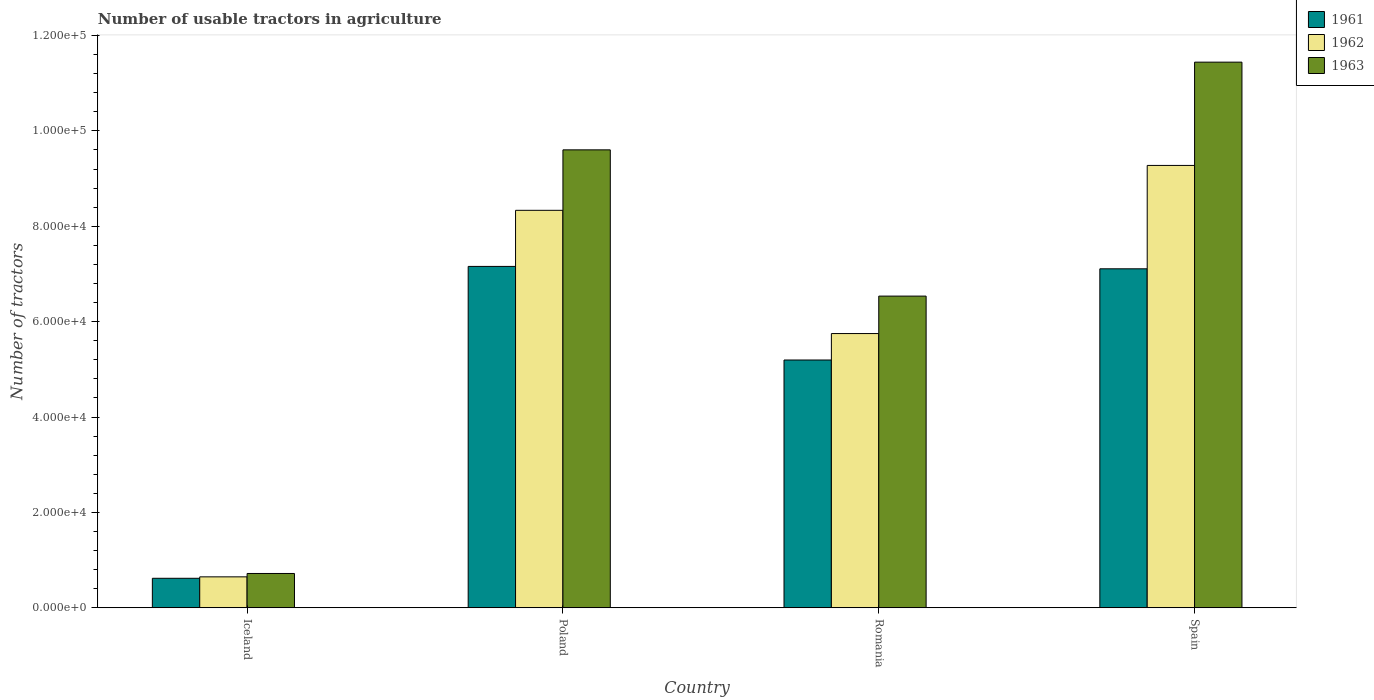How many different coloured bars are there?
Give a very brief answer. 3. How many groups of bars are there?
Your response must be concise. 4. Are the number of bars per tick equal to the number of legend labels?
Keep it short and to the point. Yes. How many bars are there on the 1st tick from the right?
Provide a succinct answer. 3. In how many cases, is the number of bars for a given country not equal to the number of legend labels?
Your answer should be compact. 0. What is the number of usable tractors in agriculture in 1961 in Spain?
Keep it short and to the point. 7.11e+04. Across all countries, what is the maximum number of usable tractors in agriculture in 1963?
Provide a succinct answer. 1.14e+05. Across all countries, what is the minimum number of usable tractors in agriculture in 1963?
Offer a very short reply. 7187. In which country was the number of usable tractors in agriculture in 1961 minimum?
Your response must be concise. Iceland. What is the total number of usable tractors in agriculture in 1963 in the graph?
Your answer should be very brief. 2.83e+05. What is the difference between the number of usable tractors in agriculture in 1962 in Poland and that in Romania?
Provide a short and direct response. 2.58e+04. What is the difference between the number of usable tractors in agriculture in 1961 in Romania and the number of usable tractors in agriculture in 1963 in Iceland?
Provide a short and direct response. 4.48e+04. What is the average number of usable tractors in agriculture in 1961 per country?
Your response must be concise. 5.02e+04. What is the difference between the number of usable tractors in agriculture of/in 1961 and number of usable tractors in agriculture of/in 1963 in Iceland?
Offer a very short reply. -1010. What is the ratio of the number of usable tractors in agriculture in 1963 in Poland to that in Romania?
Provide a short and direct response. 1.47. Is the number of usable tractors in agriculture in 1962 in Poland less than that in Romania?
Provide a short and direct response. No. Is the difference between the number of usable tractors in agriculture in 1961 in Poland and Spain greater than the difference between the number of usable tractors in agriculture in 1963 in Poland and Spain?
Your answer should be compact. Yes. What is the difference between the highest and the second highest number of usable tractors in agriculture in 1961?
Ensure brevity in your answer.  -1.96e+04. What is the difference between the highest and the lowest number of usable tractors in agriculture in 1963?
Your response must be concise. 1.07e+05. In how many countries, is the number of usable tractors in agriculture in 1963 greater than the average number of usable tractors in agriculture in 1963 taken over all countries?
Provide a short and direct response. 2. Is the sum of the number of usable tractors in agriculture in 1963 in Romania and Spain greater than the maximum number of usable tractors in agriculture in 1962 across all countries?
Make the answer very short. Yes. What does the 1st bar from the left in Iceland represents?
Make the answer very short. 1961. What does the 1st bar from the right in Poland represents?
Provide a succinct answer. 1963. Is it the case that in every country, the sum of the number of usable tractors in agriculture in 1963 and number of usable tractors in agriculture in 1961 is greater than the number of usable tractors in agriculture in 1962?
Offer a very short reply. Yes. What is the difference between two consecutive major ticks on the Y-axis?
Ensure brevity in your answer.  2.00e+04. Does the graph contain grids?
Ensure brevity in your answer.  No. How many legend labels are there?
Make the answer very short. 3. What is the title of the graph?
Offer a very short reply. Number of usable tractors in agriculture. Does "1997" appear as one of the legend labels in the graph?
Offer a terse response. No. What is the label or title of the Y-axis?
Your answer should be compact. Number of tractors. What is the Number of tractors of 1961 in Iceland?
Offer a very short reply. 6177. What is the Number of tractors of 1962 in Iceland?
Give a very brief answer. 6479. What is the Number of tractors in 1963 in Iceland?
Keep it short and to the point. 7187. What is the Number of tractors in 1961 in Poland?
Make the answer very short. 7.16e+04. What is the Number of tractors of 1962 in Poland?
Give a very brief answer. 8.33e+04. What is the Number of tractors of 1963 in Poland?
Provide a short and direct response. 9.60e+04. What is the Number of tractors in 1961 in Romania?
Provide a short and direct response. 5.20e+04. What is the Number of tractors of 1962 in Romania?
Ensure brevity in your answer.  5.75e+04. What is the Number of tractors in 1963 in Romania?
Your answer should be very brief. 6.54e+04. What is the Number of tractors in 1961 in Spain?
Make the answer very short. 7.11e+04. What is the Number of tractors in 1962 in Spain?
Your answer should be compact. 9.28e+04. What is the Number of tractors in 1963 in Spain?
Your answer should be compact. 1.14e+05. Across all countries, what is the maximum Number of tractors in 1961?
Keep it short and to the point. 7.16e+04. Across all countries, what is the maximum Number of tractors of 1962?
Your response must be concise. 9.28e+04. Across all countries, what is the maximum Number of tractors of 1963?
Make the answer very short. 1.14e+05. Across all countries, what is the minimum Number of tractors in 1961?
Give a very brief answer. 6177. Across all countries, what is the minimum Number of tractors in 1962?
Provide a short and direct response. 6479. Across all countries, what is the minimum Number of tractors in 1963?
Give a very brief answer. 7187. What is the total Number of tractors in 1961 in the graph?
Provide a short and direct response. 2.01e+05. What is the total Number of tractors in 1962 in the graph?
Your answer should be compact. 2.40e+05. What is the total Number of tractors of 1963 in the graph?
Give a very brief answer. 2.83e+05. What is the difference between the Number of tractors of 1961 in Iceland and that in Poland?
Your answer should be very brief. -6.54e+04. What is the difference between the Number of tractors of 1962 in Iceland and that in Poland?
Provide a short and direct response. -7.69e+04. What is the difference between the Number of tractors in 1963 in Iceland and that in Poland?
Offer a very short reply. -8.88e+04. What is the difference between the Number of tractors in 1961 in Iceland and that in Romania?
Your answer should be very brief. -4.58e+04. What is the difference between the Number of tractors of 1962 in Iceland and that in Romania?
Your answer should be compact. -5.10e+04. What is the difference between the Number of tractors in 1963 in Iceland and that in Romania?
Your response must be concise. -5.82e+04. What is the difference between the Number of tractors of 1961 in Iceland and that in Spain?
Keep it short and to the point. -6.49e+04. What is the difference between the Number of tractors of 1962 in Iceland and that in Spain?
Your answer should be very brief. -8.63e+04. What is the difference between the Number of tractors in 1963 in Iceland and that in Spain?
Ensure brevity in your answer.  -1.07e+05. What is the difference between the Number of tractors of 1961 in Poland and that in Romania?
Keep it short and to the point. 1.96e+04. What is the difference between the Number of tractors of 1962 in Poland and that in Romania?
Provide a short and direct response. 2.58e+04. What is the difference between the Number of tractors of 1963 in Poland and that in Romania?
Your answer should be compact. 3.07e+04. What is the difference between the Number of tractors of 1962 in Poland and that in Spain?
Your response must be concise. -9414. What is the difference between the Number of tractors in 1963 in Poland and that in Spain?
Your answer should be compact. -1.84e+04. What is the difference between the Number of tractors of 1961 in Romania and that in Spain?
Your response must be concise. -1.91e+04. What is the difference between the Number of tractors in 1962 in Romania and that in Spain?
Offer a terse response. -3.53e+04. What is the difference between the Number of tractors of 1963 in Romania and that in Spain?
Keep it short and to the point. -4.91e+04. What is the difference between the Number of tractors of 1961 in Iceland and the Number of tractors of 1962 in Poland?
Offer a very short reply. -7.72e+04. What is the difference between the Number of tractors of 1961 in Iceland and the Number of tractors of 1963 in Poland?
Ensure brevity in your answer.  -8.98e+04. What is the difference between the Number of tractors of 1962 in Iceland and the Number of tractors of 1963 in Poland?
Keep it short and to the point. -8.95e+04. What is the difference between the Number of tractors of 1961 in Iceland and the Number of tractors of 1962 in Romania?
Give a very brief answer. -5.13e+04. What is the difference between the Number of tractors of 1961 in Iceland and the Number of tractors of 1963 in Romania?
Provide a short and direct response. -5.92e+04. What is the difference between the Number of tractors in 1962 in Iceland and the Number of tractors in 1963 in Romania?
Offer a terse response. -5.89e+04. What is the difference between the Number of tractors in 1961 in Iceland and the Number of tractors in 1962 in Spain?
Ensure brevity in your answer.  -8.66e+04. What is the difference between the Number of tractors in 1961 in Iceland and the Number of tractors in 1963 in Spain?
Give a very brief answer. -1.08e+05. What is the difference between the Number of tractors of 1962 in Iceland and the Number of tractors of 1963 in Spain?
Provide a succinct answer. -1.08e+05. What is the difference between the Number of tractors in 1961 in Poland and the Number of tractors in 1962 in Romania?
Offer a terse response. 1.41e+04. What is the difference between the Number of tractors in 1961 in Poland and the Number of tractors in 1963 in Romania?
Offer a very short reply. 6226. What is the difference between the Number of tractors in 1962 in Poland and the Number of tractors in 1963 in Romania?
Offer a very short reply. 1.80e+04. What is the difference between the Number of tractors in 1961 in Poland and the Number of tractors in 1962 in Spain?
Offer a very short reply. -2.12e+04. What is the difference between the Number of tractors of 1961 in Poland and the Number of tractors of 1963 in Spain?
Provide a short and direct response. -4.28e+04. What is the difference between the Number of tractors in 1962 in Poland and the Number of tractors in 1963 in Spain?
Provide a succinct answer. -3.11e+04. What is the difference between the Number of tractors in 1961 in Romania and the Number of tractors in 1962 in Spain?
Offer a very short reply. -4.08e+04. What is the difference between the Number of tractors of 1961 in Romania and the Number of tractors of 1963 in Spain?
Provide a short and direct response. -6.25e+04. What is the difference between the Number of tractors in 1962 in Romania and the Number of tractors in 1963 in Spain?
Make the answer very short. -5.69e+04. What is the average Number of tractors in 1961 per country?
Provide a succinct answer. 5.02e+04. What is the average Number of tractors of 1962 per country?
Offer a terse response. 6.00e+04. What is the average Number of tractors of 1963 per country?
Your response must be concise. 7.07e+04. What is the difference between the Number of tractors of 1961 and Number of tractors of 1962 in Iceland?
Offer a very short reply. -302. What is the difference between the Number of tractors in 1961 and Number of tractors in 1963 in Iceland?
Keep it short and to the point. -1010. What is the difference between the Number of tractors in 1962 and Number of tractors in 1963 in Iceland?
Keep it short and to the point. -708. What is the difference between the Number of tractors of 1961 and Number of tractors of 1962 in Poland?
Provide a short and direct response. -1.18e+04. What is the difference between the Number of tractors of 1961 and Number of tractors of 1963 in Poland?
Your response must be concise. -2.44e+04. What is the difference between the Number of tractors in 1962 and Number of tractors in 1963 in Poland?
Make the answer very short. -1.27e+04. What is the difference between the Number of tractors in 1961 and Number of tractors in 1962 in Romania?
Provide a short and direct response. -5548. What is the difference between the Number of tractors in 1961 and Number of tractors in 1963 in Romania?
Offer a very short reply. -1.34e+04. What is the difference between the Number of tractors of 1962 and Number of tractors of 1963 in Romania?
Offer a very short reply. -7851. What is the difference between the Number of tractors of 1961 and Number of tractors of 1962 in Spain?
Give a very brief answer. -2.17e+04. What is the difference between the Number of tractors in 1961 and Number of tractors in 1963 in Spain?
Keep it short and to the point. -4.33e+04. What is the difference between the Number of tractors in 1962 and Number of tractors in 1963 in Spain?
Provide a short and direct response. -2.17e+04. What is the ratio of the Number of tractors of 1961 in Iceland to that in Poland?
Make the answer very short. 0.09. What is the ratio of the Number of tractors in 1962 in Iceland to that in Poland?
Provide a short and direct response. 0.08. What is the ratio of the Number of tractors in 1963 in Iceland to that in Poland?
Offer a very short reply. 0.07. What is the ratio of the Number of tractors of 1961 in Iceland to that in Romania?
Offer a terse response. 0.12. What is the ratio of the Number of tractors in 1962 in Iceland to that in Romania?
Offer a terse response. 0.11. What is the ratio of the Number of tractors of 1963 in Iceland to that in Romania?
Offer a terse response. 0.11. What is the ratio of the Number of tractors in 1961 in Iceland to that in Spain?
Your answer should be very brief. 0.09. What is the ratio of the Number of tractors in 1962 in Iceland to that in Spain?
Your response must be concise. 0.07. What is the ratio of the Number of tractors in 1963 in Iceland to that in Spain?
Provide a succinct answer. 0.06. What is the ratio of the Number of tractors in 1961 in Poland to that in Romania?
Your response must be concise. 1.38. What is the ratio of the Number of tractors of 1962 in Poland to that in Romania?
Provide a short and direct response. 1.45. What is the ratio of the Number of tractors of 1963 in Poland to that in Romania?
Provide a short and direct response. 1.47. What is the ratio of the Number of tractors of 1962 in Poland to that in Spain?
Your answer should be very brief. 0.9. What is the ratio of the Number of tractors in 1963 in Poland to that in Spain?
Keep it short and to the point. 0.84. What is the ratio of the Number of tractors in 1961 in Romania to that in Spain?
Give a very brief answer. 0.73. What is the ratio of the Number of tractors in 1962 in Romania to that in Spain?
Your response must be concise. 0.62. What is the ratio of the Number of tractors in 1963 in Romania to that in Spain?
Give a very brief answer. 0.57. What is the difference between the highest and the second highest Number of tractors of 1962?
Ensure brevity in your answer.  9414. What is the difference between the highest and the second highest Number of tractors in 1963?
Provide a short and direct response. 1.84e+04. What is the difference between the highest and the lowest Number of tractors in 1961?
Offer a terse response. 6.54e+04. What is the difference between the highest and the lowest Number of tractors of 1962?
Keep it short and to the point. 8.63e+04. What is the difference between the highest and the lowest Number of tractors of 1963?
Give a very brief answer. 1.07e+05. 